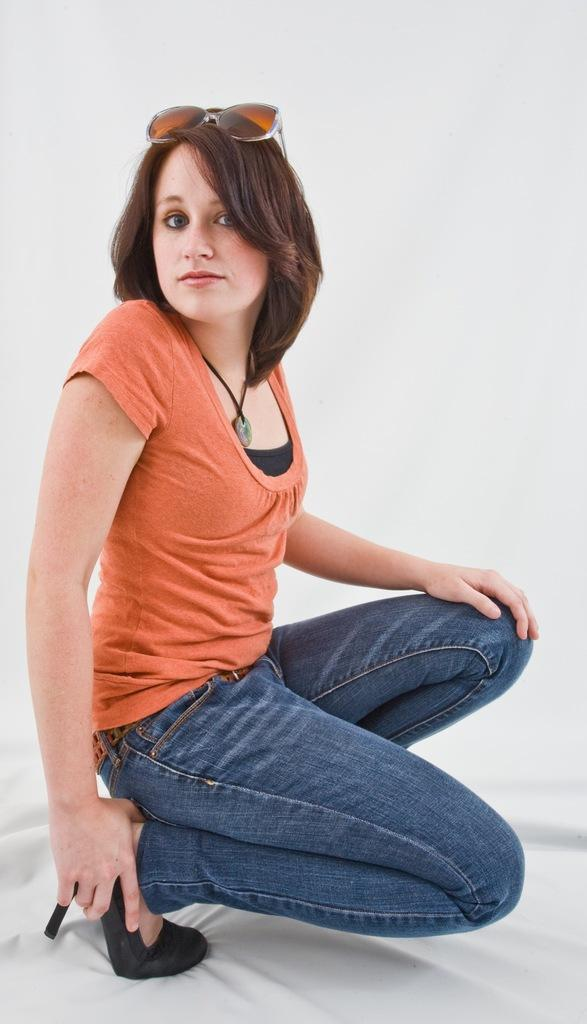Who is the main subject in the image? There is a lady in the image. What is the lady sitting on? The lady is sitting on a cloth. What accessory is the lady wearing on her head? The lady is wearing sunglasses on her head. How many mice are crawling on the lady's arm in the image? There are no mice present in the image. What type of nail is the lady using to paint her nails in the image? There is no nail or nail painting activity depicted in the image. 